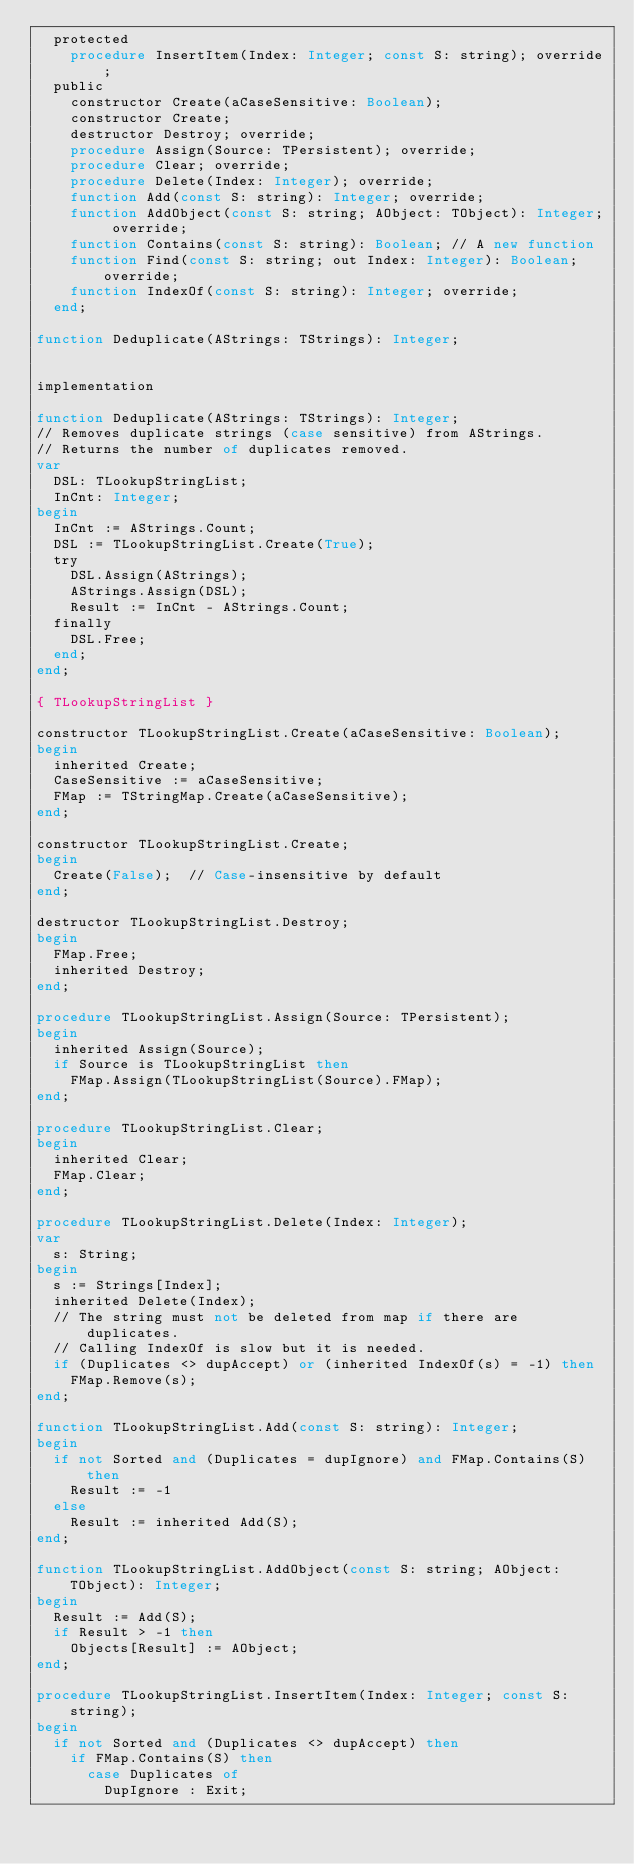<code> <loc_0><loc_0><loc_500><loc_500><_Pascal_>  protected
    procedure InsertItem(Index: Integer; const S: string); override;
  public
    constructor Create(aCaseSensitive: Boolean);
    constructor Create;
    destructor Destroy; override;
    procedure Assign(Source: TPersistent); override;
    procedure Clear; override;
    procedure Delete(Index: Integer); override;
    function Add(const S: string): Integer; override;
    function AddObject(const S: string; AObject: TObject): Integer; override;
    function Contains(const S: string): Boolean; // A new function
    function Find(const S: string; out Index: Integer): Boolean; override;
    function IndexOf(const S: string): Integer; override;
  end;

function Deduplicate(AStrings: TStrings): Integer;


implementation

function Deduplicate(AStrings: TStrings): Integer;
// Removes duplicate strings (case sensitive) from AStrings.
// Returns the number of duplicates removed.
var
  DSL: TLookupStringList;
  InCnt: Integer;
begin
  InCnt := AStrings.Count;
  DSL := TLookupStringList.Create(True);
  try
    DSL.Assign(AStrings);
    AStrings.Assign(DSL);
    Result := InCnt - AStrings.Count;
  finally
    DSL.Free;
  end;
end;

{ TLookupStringList }

constructor TLookupStringList.Create(aCaseSensitive: Boolean);
begin
  inherited Create;
  CaseSensitive := aCaseSensitive;
  FMap := TStringMap.Create(aCaseSensitive);
end;

constructor TLookupStringList.Create;
begin
  Create(False);  // Case-insensitive by default
end;

destructor TLookupStringList.Destroy;
begin
  FMap.Free;
  inherited Destroy;
end;

procedure TLookupStringList.Assign(Source: TPersistent);
begin
  inherited Assign(Source);
  if Source is TLookupStringList then
    FMap.Assign(TLookupStringList(Source).FMap);
end;

procedure TLookupStringList.Clear;
begin
  inherited Clear;
  FMap.Clear;
end;

procedure TLookupStringList.Delete(Index: Integer);
var
  s: String;
begin
  s := Strings[Index];
  inherited Delete(Index);
  // The string must not be deleted from map if there are duplicates.
  // Calling IndexOf is slow but it is needed.
  if (Duplicates <> dupAccept) or (inherited IndexOf(s) = -1) then
    FMap.Remove(s);
end;

function TLookupStringList.Add(const S: string): Integer;
begin
  if not Sorted and (Duplicates = dupIgnore) and FMap.Contains(S) then
    Result := -1
  else
    Result := inherited Add(S);
end;

function TLookupStringList.AddObject(const S: string; AObject: TObject): Integer;
begin
  Result := Add(S);
  if Result > -1 then
    Objects[Result] := AObject;
end;

procedure TLookupStringList.InsertItem(Index: Integer; const S: string);
begin
  if not Sorted and (Duplicates <> dupAccept) then
    if FMap.Contains(S) then
      case Duplicates of
        DupIgnore : Exit;</code> 